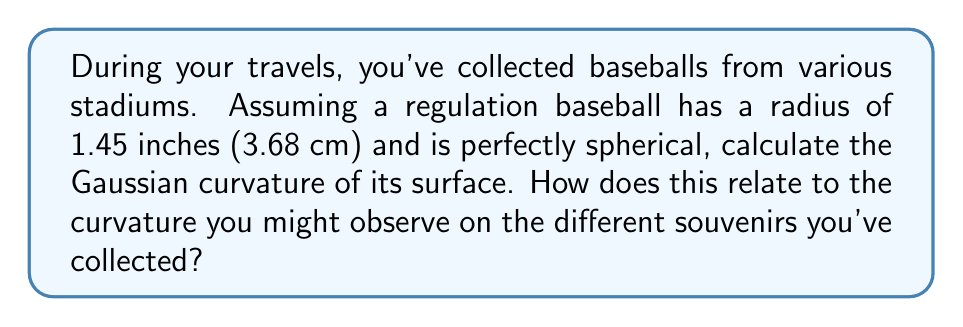Teach me how to tackle this problem. Let's approach this step-by-step:

1) The Gaussian curvature of a surface is the product of its two principal curvatures. For a sphere, these principal curvatures are equal and constant at every point.

2) For a sphere of radius $r$, the principal curvatures are both equal to $\frac{1}{r}$.

3) Therefore, the Gaussian curvature $K$ of a sphere is given by:

   $$K = \frac{1}{r} \cdot \frac{1}{r} = \frac{1}{r^2}$$

4) We're given that the radius of a regulation baseball is 1.45 inches or 3.68 cm. Let's use the metric unit for our calculation.

5) Substituting $r = 3.68$ cm into our formula:

   $$K = \frac{1}{(3.68\text{ cm})^2} = \frac{1}{13.5424\text{ cm}^2} \approx 0.0738\text{ cm}^{-2}$$

6) This constant curvature applies to every point on the baseball's surface.

7) Regarding the souvenirs collected: Assuming all the baseballs are regulation size, they should all have the same Gaussian curvature. However, in reality, there might be slight variations due to manufacturing tolerances or wear and tear. These variations would be minimal and likely unnoticeable to the naked eye.
Answer: $0.0738\text{ cm}^{-2}$ 